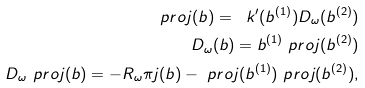<formula> <loc_0><loc_0><loc_500><loc_500>\ p r o j ( b ) = \ k ^ { \prime } ( b ^ { ( 1 ) } ) D _ { \omega } ( b ^ { ( 2 ) } ) \\ D _ { \omega } ( b ) = b ^ { ( 1 ) } \ p r o j ( b ^ { ( 2 ) } ) \\ D _ { \omega } \ p r o j ( b ) = - R _ { \omega } \pi j ( b ) - \ p r o j ( b ^ { ( 1 ) } ) \ p r o j ( b ^ { ( 2 ) } ) ,</formula> 